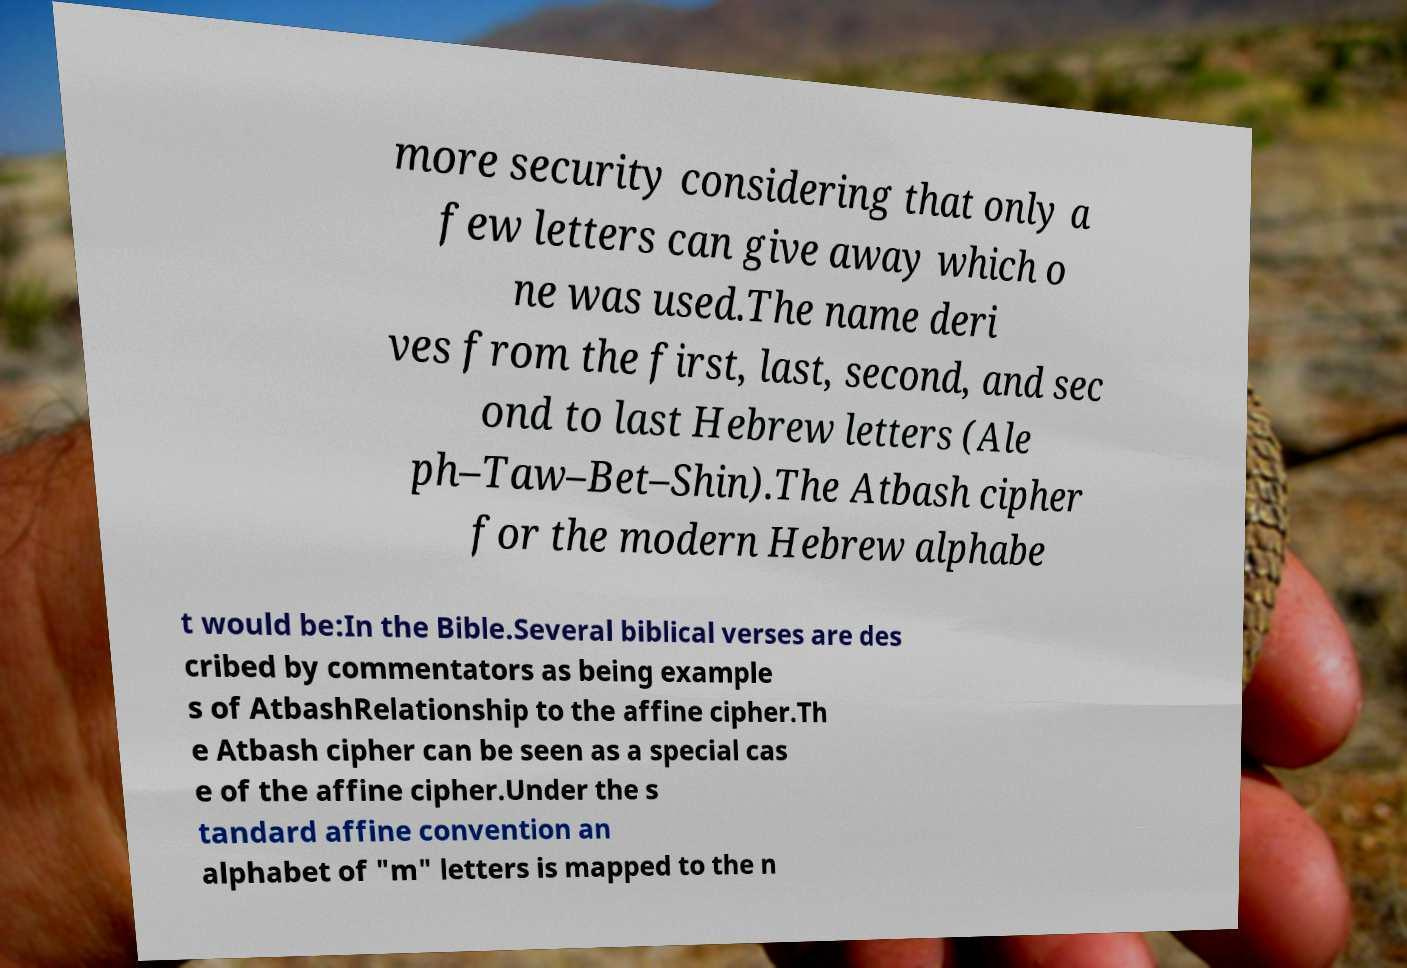There's text embedded in this image that I need extracted. Can you transcribe it verbatim? more security considering that only a few letters can give away which o ne was used.The name deri ves from the first, last, second, and sec ond to last Hebrew letters (Ale ph–Taw–Bet–Shin).The Atbash cipher for the modern Hebrew alphabe t would be:In the Bible.Several biblical verses are des cribed by commentators as being example s of AtbashRelationship to the affine cipher.Th e Atbash cipher can be seen as a special cas e of the affine cipher.Under the s tandard affine convention an alphabet of "m" letters is mapped to the n 